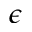Convert formula to latex. <formula><loc_0><loc_0><loc_500><loc_500>\epsilon</formula> 